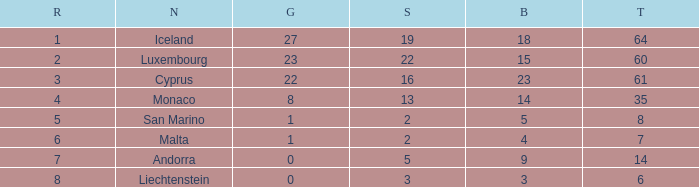Where does Iceland rank with under 19 silvers? None. 